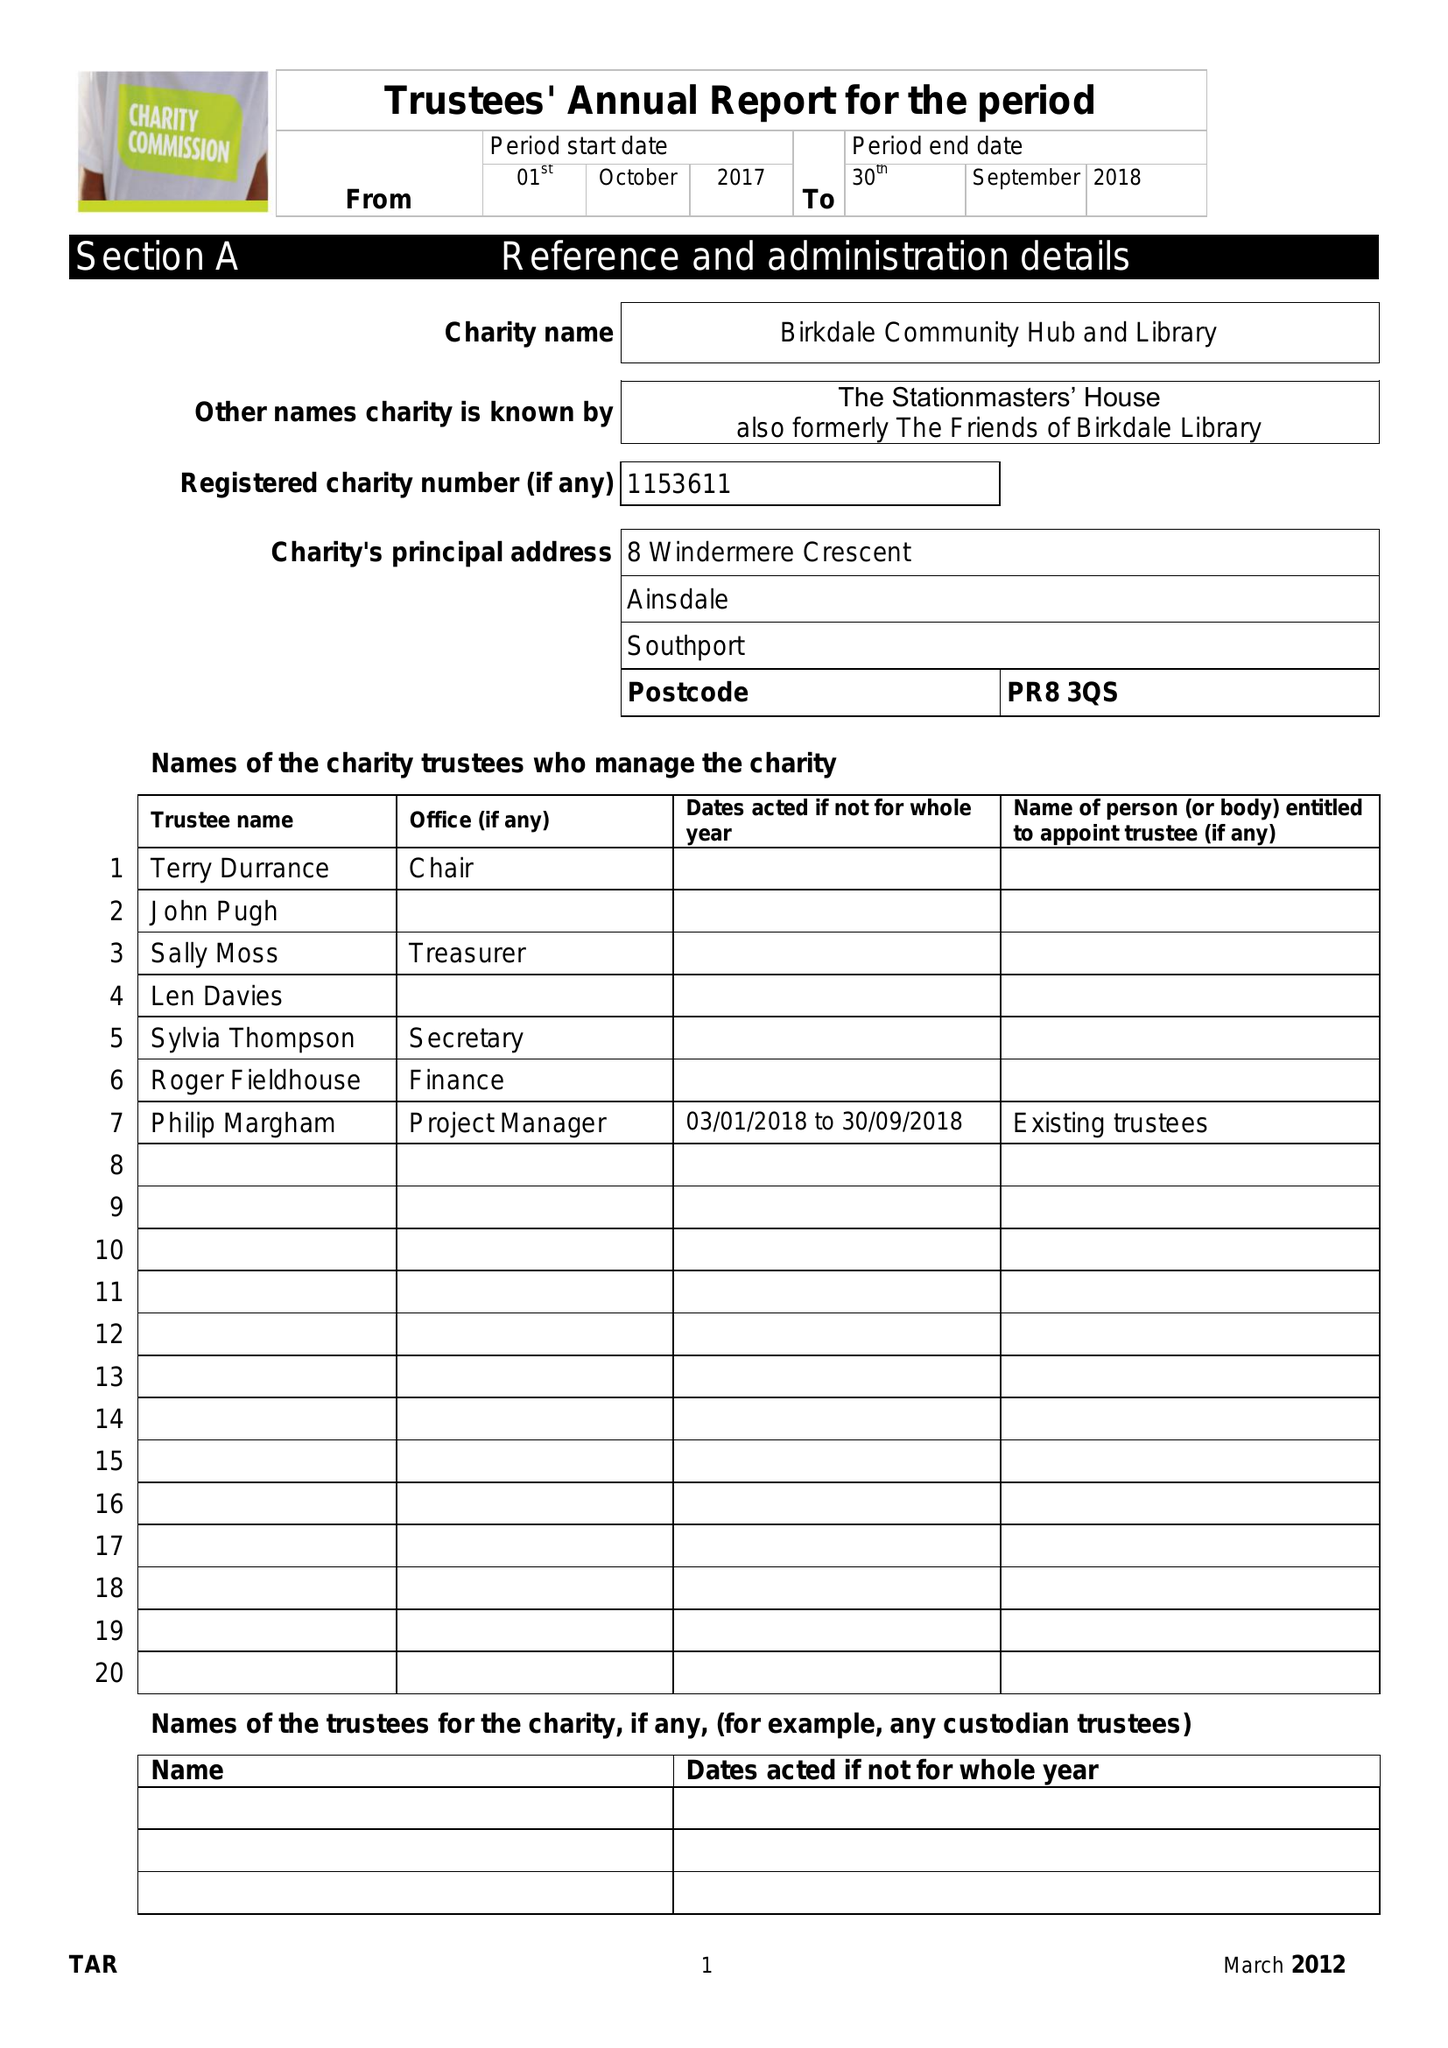What is the value for the address__postcode?
Answer the question using a single word or phrase. PR8 3QS 